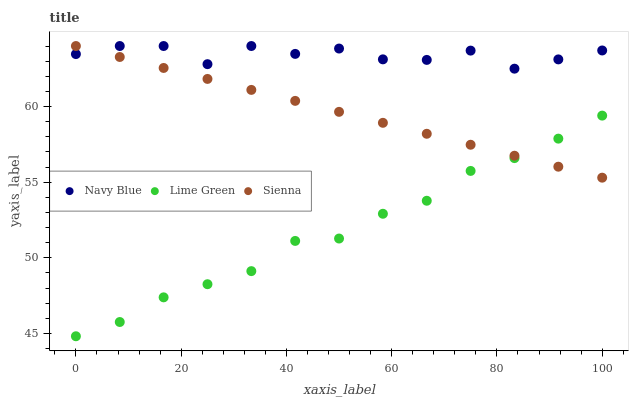Does Lime Green have the minimum area under the curve?
Answer yes or no. Yes. Does Navy Blue have the maximum area under the curve?
Answer yes or no. Yes. Does Navy Blue have the minimum area under the curve?
Answer yes or no. No. Does Lime Green have the maximum area under the curve?
Answer yes or no. No. Is Sienna the smoothest?
Answer yes or no. Yes. Is Navy Blue the roughest?
Answer yes or no. Yes. Is Lime Green the smoothest?
Answer yes or no. No. Is Lime Green the roughest?
Answer yes or no. No. Does Lime Green have the lowest value?
Answer yes or no. Yes. Does Navy Blue have the lowest value?
Answer yes or no. No. Does Navy Blue have the highest value?
Answer yes or no. Yes. Does Lime Green have the highest value?
Answer yes or no. No. Is Lime Green less than Navy Blue?
Answer yes or no. Yes. Is Navy Blue greater than Lime Green?
Answer yes or no. Yes. Does Sienna intersect Lime Green?
Answer yes or no. Yes. Is Sienna less than Lime Green?
Answer yes or no. No. Is Sienna greater than Lime Green?
Answer yes or no. No. Does Lime Green intersect Navy Blue?
Answer yes or no. No. 